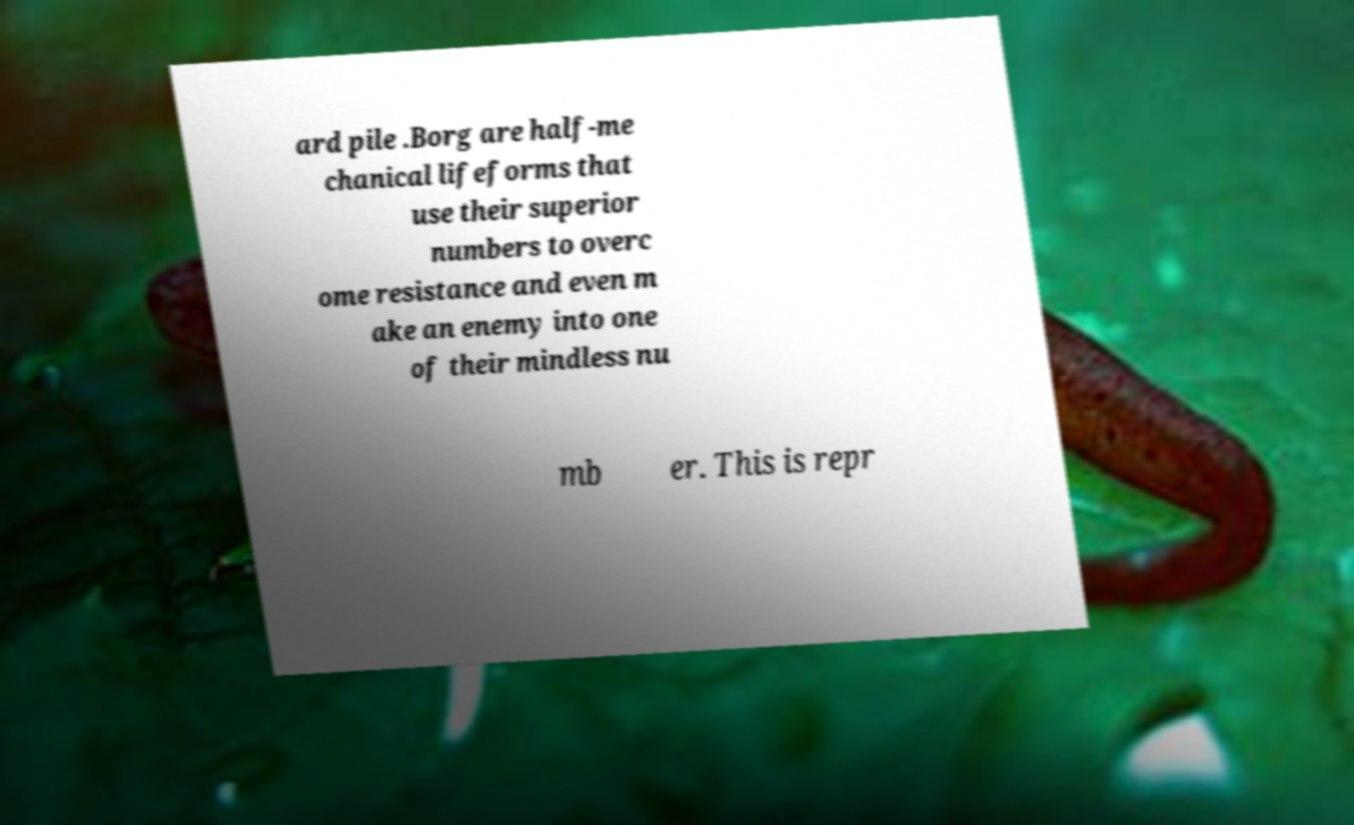There's text embedded in this image that I need extracted. Can you transcribe it verbatim? ard pile .Borg are half-me chanical lifeforms that use their superior numbers to overc ome resistance and even m ake an enemy into one of their mindless nu mb er. This is repr 